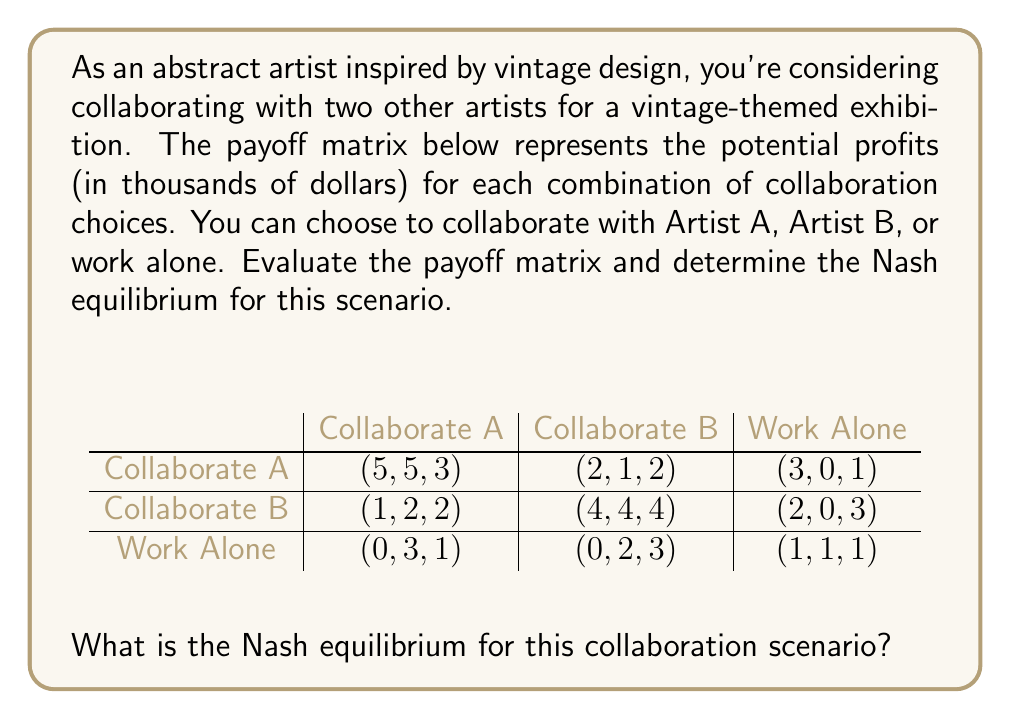Show me your answer to this math problem. To find the Nash equilibrium, we need to analyze each player's best response to the other players' strategies. In this case, we have three players: You, Artist A, and Artist B.

1. First, let's examine each player's payoffs for different strategy combinations:

   For You:
   - Collaborate A: max(5, 2, 3) = 5
   - Collaborate B: max(1, 4, 2) = 4
   - Work Alone: max(0, 0, 1) = 1

   For Artist A:
   - Collaborate A: max(5, 1, 3) = 5
   - Collaborate B: max(2, 4, 2) = 4
   - Work Alone: max(0, 0, 1) = 1

   For Artist B:
   - Collaborate A: max(3, 2, 1) = 3
   - Collaborate B: max(2, 4, 3) = 4
   - Work Alone: max(1, 3, 1) = 3

2. Now, we look for a strategy combination where no player can unilaterally improve their payoff by changing their strategy.

3. The strategy combination (Collaborate A, Collaborate A, Collaborate B) yields payoffs (5, 5, 3).
   - You can't improve your payoff by changing strategy.
   - Artist A can't improve their payoff by changing strategy.
   - Artist B can improve their payoff from 3 to 4 by switching to Collaborate B.

4. The strategy combination (Collaborate B, Collaborate B, Collaborate B) yields payoffs (4, 4, 4).
   - You can improve your payoff from 4 to 5 by switching to Collaborate A.
   - Artist A can improve their payoff from 4 to 5 by switching to Collaborate A.
   - Artist B can't improve their payoff by changing strategy.

5. The only strategy combination where no player can unilaterally improve their payoff is (Collaborate A, Collaborate A, Collaborate B).

Therefore, the Nash equilibrium for this collaboration scenario is (Collaborate A, Collaborate A, Collaborate B).
Answer: The Nash equilibrium is (Collaborate A, Collaborate A, Collaborate B), resulting in payoffs of (5, 5, 3) for You, Artist A, and Artist B, respectively. 